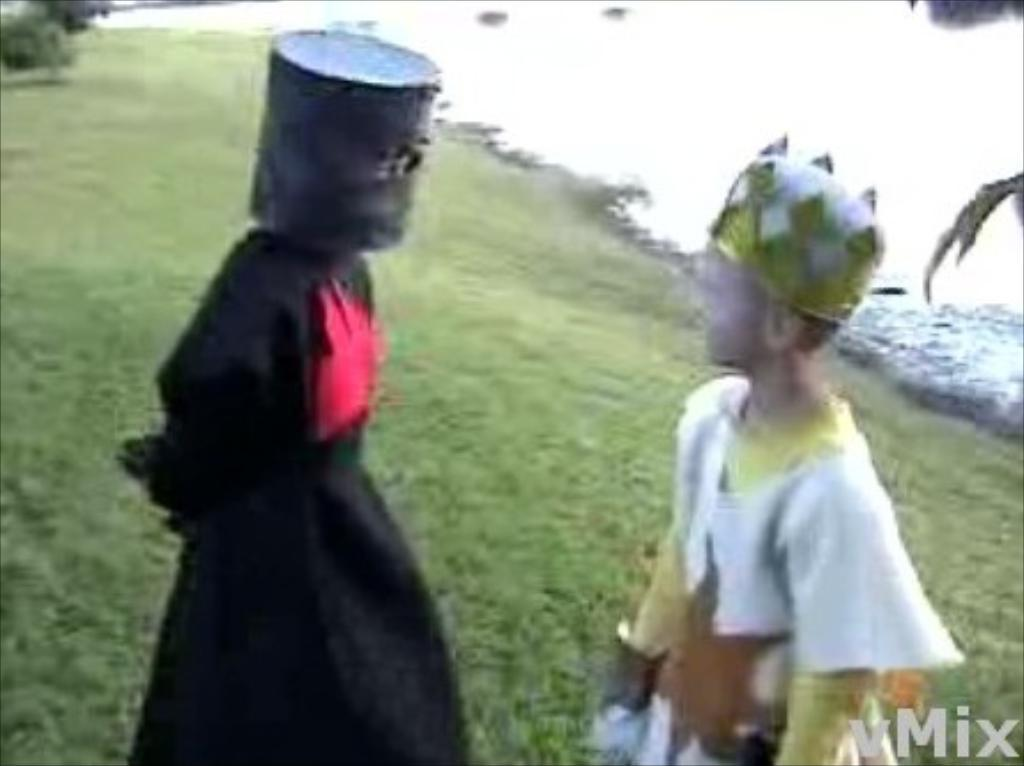How many people are in the image? There are two persons in the image. What are the persons wearing? The persons are wearing costumes. What type of surface is visible at the bottom of the image? There is grass at the bottom of the image. Is there any text or logo visible in the image? Yes, there is a watermark in the image. Can you see any paper blowing in the wind in the image? There is no paper visible in the image, nor is there any wind depicted. --- Facts: 1. There is a car in the image. 2. The car is red. 3. The car has four wheels. 4. There is a road in the image. 5. The road is paved. Absurd Topics: parrot, ocean, mountain Conversation: What is the main subject of the image? The main subject of the image is a car. What color is the car? The car is red. How many wheels does the car have? The car has four wheels. What type of surface is visible in the image? There is a road in the image. What is the condition of the road? The road is paved. Reasoning: Let's think step by step in order to produce the conversation. We start by identifying the main subject of the image, which is the car. Then, we describe the car's color and the number of wheels it has. Next, we mention the type of surface visible in the image, which is a road. Finally, we describe the condition of the road, noting that it is paved. Absurd Question/Answer: Can you see any parrots flying over the car in the image? There are no parrots visible in the image, nor is there any indication of birds or wildlife. --- Facts: 1. There is a person holding a camera in the image. 2. The person is wearing a hat. 3. The person is standing on a bridge. 4. There is a river below the bridge. 5. The sky is visible in the image. Absurd Topics: snow, elephant, dance Conversation: What is the person in the image doing? The person is holding a camera in the image. What type of clothing is the person wearing? The person is wearing a hat. Where is the person standing in the image? The person is standing on a bridge. What is visible below the bridge? There is a river below the bridge. What is visible at the top of the image? The sky is visible in the image. Reasoning: Let's think step by step in order to produce the conversation. We start by identifying the main subject of the image, which is 